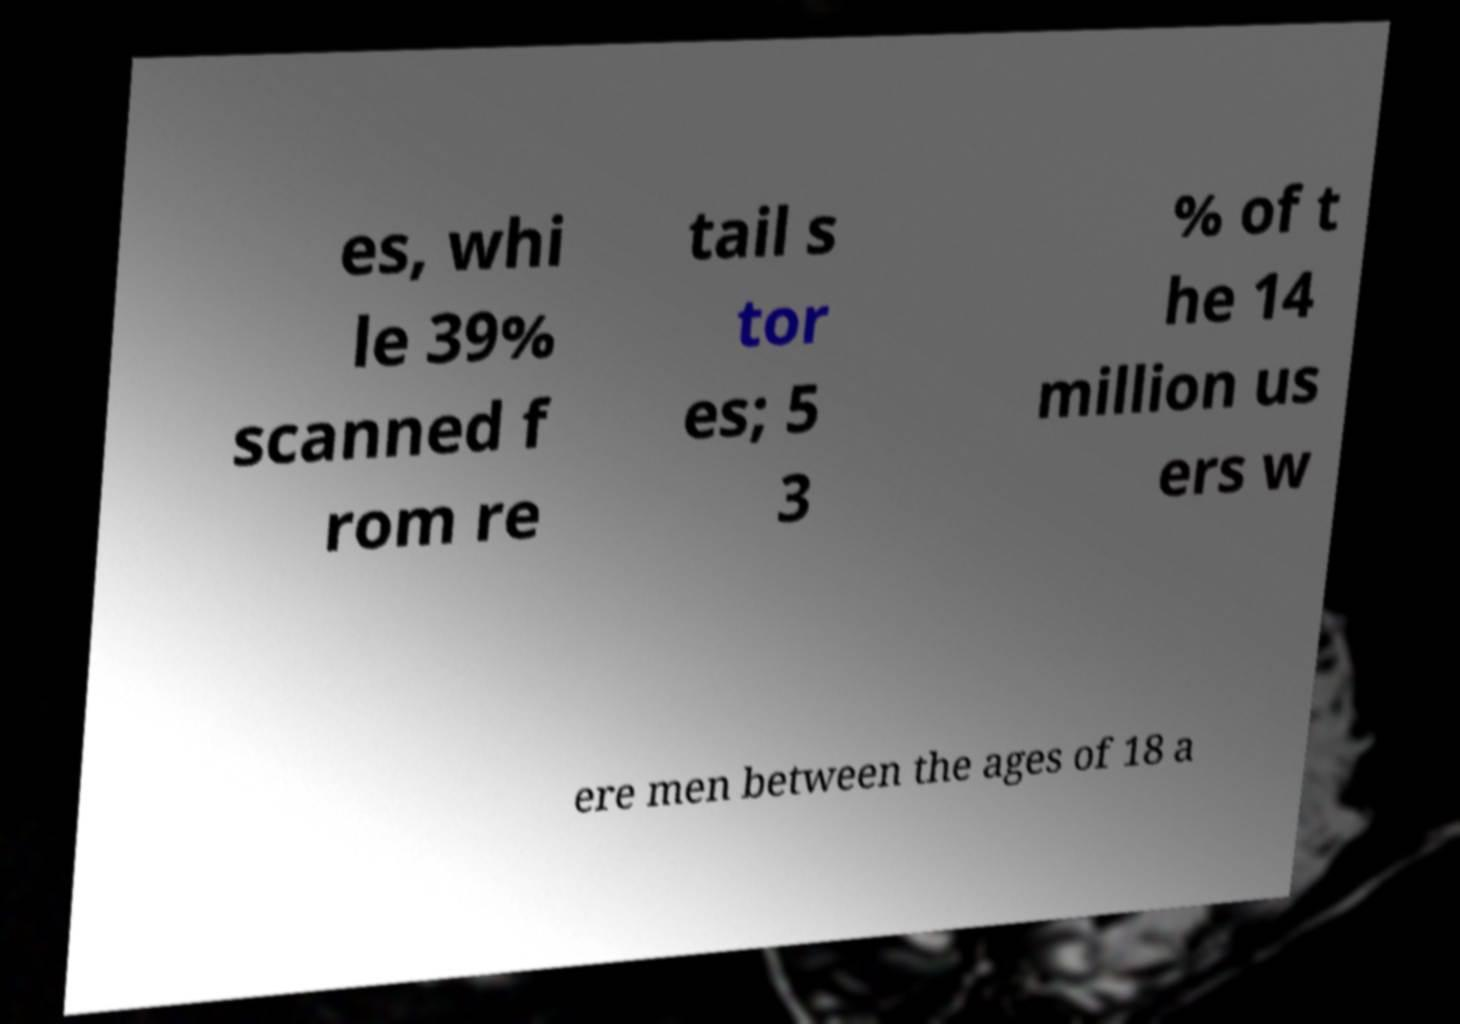Can you read and provide the text displayed in the image?This photo seems to have some interesting text. Can you extract and type it out for me? es, whi le 39% scanned f rom re tail s tor es; 5 3 % of t he 14 million us ers w ere men between the ages of 18 a 